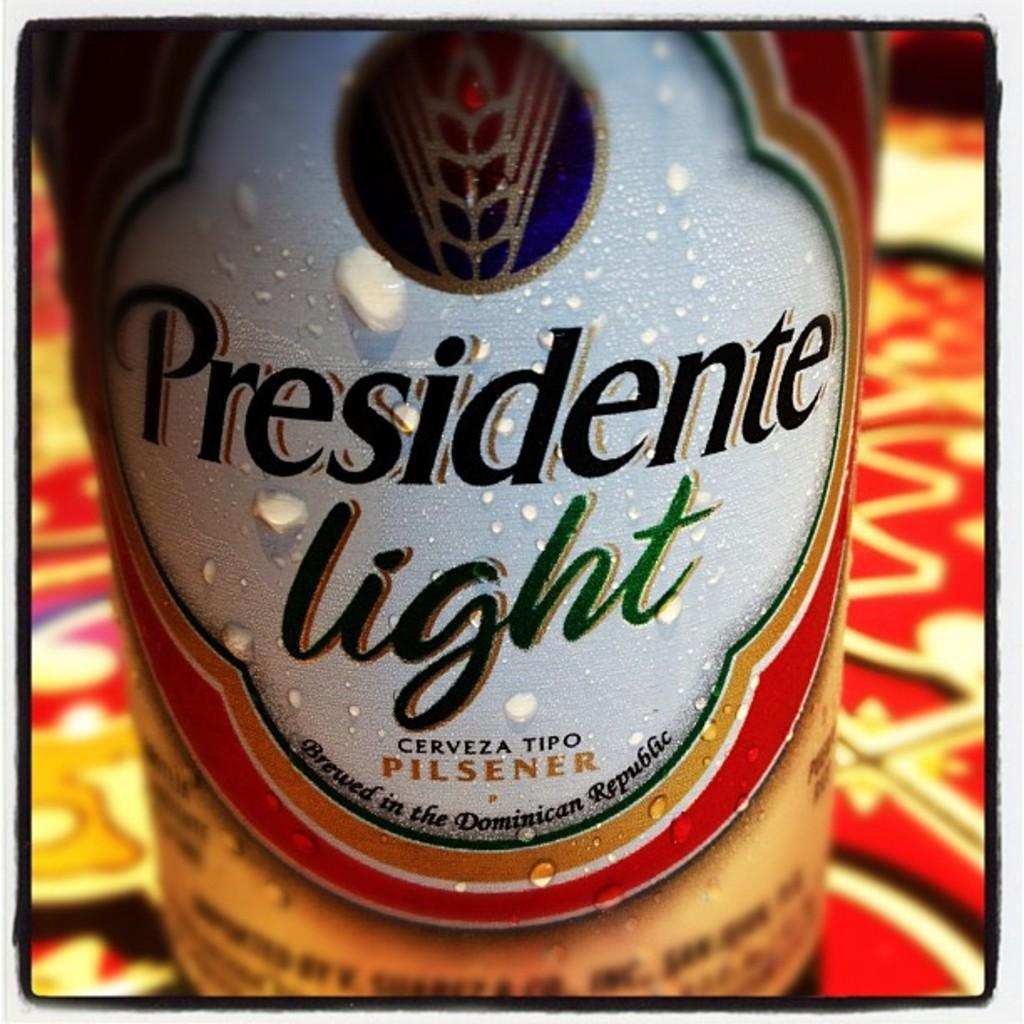<image>
Summarize the visual content of the image. Droplets of moisture dot a Presidente light Pilsner label. 